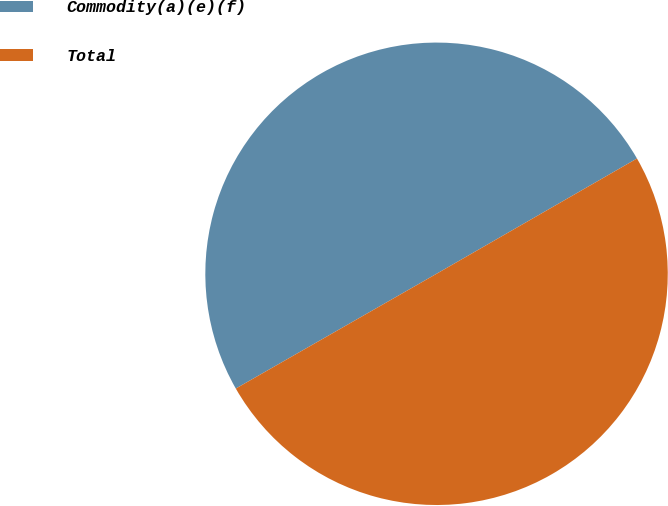Convert chart. <chart><loc_0><loc_0><loc_500><loc_500><pie_chart><fcel>Commodity(a)(e)(f)<fcel>Total<nl><fcel>49.96%<fcel>50.04%<nl></chart> 